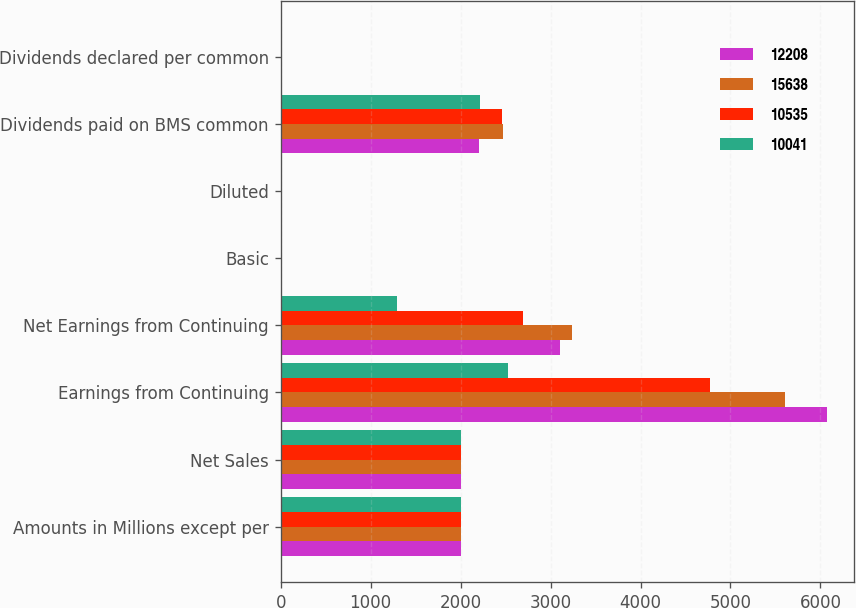Convert chart to OTSL. <chart><loc_0><loc_0><loc_500><loc_500><stacked_bar_chart><ecel><fcel>Amounts in Millions except per<fcel>Net Sales<fcel>Earnings from Continuing<fcel>Net Earnings from Continuing<fcel>Basic<fcel>Diluted<fcel>Dividends paid on BMS common<fcel>Dividends declared per common<nl><fcel>12208<fcel>2010<fcel>2007.5<fcel>6071<fcel>3102<fcel>1.8<fcel>1.79<fcel>2202<fcel>1.29<nl><fcel>15638<fcel>2009<fcel>2007.5<fcel>5602<fcel>3239<fcel>1.63<fcel>1.63<fcel>2466<fcel>1.25<nl><fcel>10535<fcel>2008<fcel>2007.5<fcel>4776<fcel>2697<fcel>1.36<fcel>1.35<fcel>2461<fcel>1.24<nl><fcel>10041<fcel>2007<fcel>2007.5<fcel>2523<fcel>1296<fcel>0.65<fcel>0.65<fcel>2213<fcel>1.15<nl></chart> 